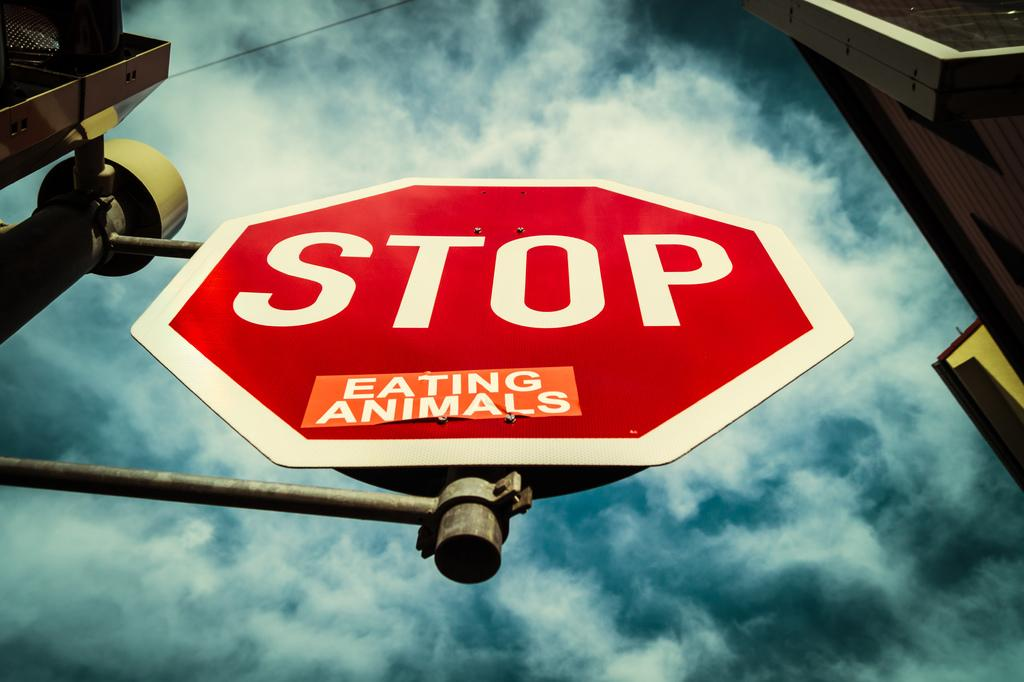Provide a one-sentence caption for the provided image. a stop sign that also says to stop eating animals. 